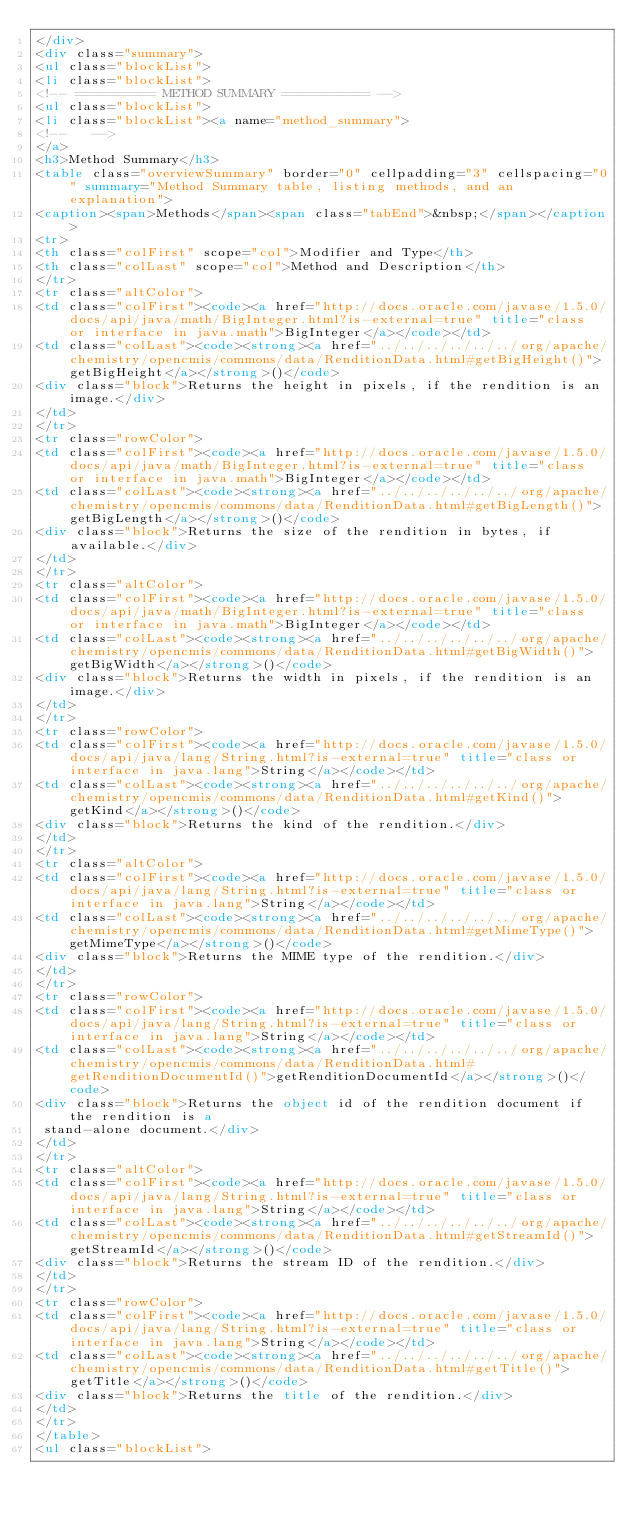Convert code to text. <code><loc_0><loc_0><loc_500><loc_500><_HTML_></div>
<div class="summary">
<ul class="blockList">
<li class="blockList">
<!-- ========== METHOD SUMMARY =========== -->
<ul class="blockList">
<li class="blockList"><a name="method_summary">
<!--   -->
</a>
<h3>Method Summary</h3>
<table class="overviewSummary" border="0" cellpadding="3" cellspacing="0" summary="Method Summary table, listing methods, and an explanation">
<caption><span>Methods</span><span class="tabEnd">&nbsp;</span></caption>
<tr>
<th class="colFirst" scope="col">Modifier and Type</th>
<th class="colLast" scope="col">Method and Description</th>
</tr>
<tr class="altColor">
<td class="colFirst"><code><a href="http://docs.oracle.com/javase/1.5.0/docs/api/java/math/BigInteger.html?is-external=true" title="class or interface in java.math">BigInteger</a></code></td>
<td class="colLast"><code><strong><a href="../../../../../../org/apache/chemistry/opencmis/commons/data/RenditionData.html#getBigHeight()">getBigHeight</a></strong>()</code>
<div class="block">Returns the height in pixels, if the rendition is an image.</div>
</td>
</tr>
<tr class="rowColor">
<td class="colFirst"><code><a href="http://docs.oracle.com/javase/1.5.0/docs/api/java/math/BigInteger.html?is-external=true" title="class or interface in java.math">BigInteger</a></code></td>
<td class="colLast"><code><strong><a href="../../../../../../org/apache/chemistry/opencmis/commons/data/RenditionData.html#getBigLength()">getBigLength</a></strong>()</code>
<div class="block">Returns the size of the rendition in bytes, if available.</div>
</td>
</tr>
<tr class="altColor">
<td class="colFirst"><code><a href="http://docs.oracle.com/javase/1.5.0/docs/api/java/math/BigInteger.html?is-external=true" title="class or interface in java.math">BigInteger</a></code></td>
<td class="colLast"><code><strong><a href="../../../../../../org/apache/chemistry/opencmis/commons/data/RenditionData.html#getBigWidth()">getBigWidth</a></strong>()</code>
<div class="block">Returns the width in pixels, if the rendition is an image.</div>
</td>
</tr>
<tr class="rowColor">
<td class="colFirst"><code><a href="http://docs.oracle.com/javase/1.5.0/docs/api/java/lang/String.html?is-external=true" title="class or interface in java.lang">String</a></code></td>
<td class="colLast"><code><strong><a href="../../../../../../org/apache/chemistry/opencmis/commons/data/RenditionData.html#getKind()">getKind</a></strong>()</code>
<div class="block">Returns the kind of the rendition.</div>
</td>
</tr>
<tr class="altColor">
<td class="colFirst"><code><a href="http://docs.oracle.com/javase/1.5.0/docs/api/java/lang/String.html?is-external=true" title="class or interface in java.lang">String</a></code></td>
<td class="colLast"><code><strong><a href="../../../../../../org/apache/chemistry/opencmis/commons/data/RenditionData.html#getMimeType()">getMimeType</a></strong>()</code>
<div class="block">Returns the MIME type of the rendition.</div>
</td>
</tr>
<tr class="rowColor">
<td class="colFirst"><code><a href="http://docs.oracle.com/javase/1.5.0/docs/api/java/lang/String.html?is-external=true" title="class or interface in java.lang">String</a></code></td>
<td class="colLast"><code><strong><a href="../../../../../../org/apache/chemistry/opencmis/commons/data/RenditionData.html#getRenditionDocumentId()">getRenditionDocumentId</a></strong>()</code>
<div class="block">Returns the object id of the rendition document if the rendition is a
 stand-alone document.</div>
</td>
</tr>
<tr class="altColor">
<td class="colFirst"><code><a href="http://docs.oracle.com/javase/1.5.0/docs/api/java/lang/String.html?is-external=true" title="class or interface in java.lang">String</a></code></td>
<td class="colLast"><code><strong><a href="../../../../../../org/apache/chemistry/opencmis/commons/data/RenditionData.html#getStreamId()">getStreamId</a></strong>()</code>
<div class="block">Returns the stream ID of the rendition.</div>
</td>
</tr>
<tr class="rowColor">
<td class="colFirst"><code><a href="http://docs.oracle.com/javase/1.5.0/docs/api/java/lang/String.html?is-external=true" title="class or interface in java.lang">String</a></code></td>
<td class="colLast"><code><strong><a href="../../../../../../org/apache/chemistry/opencmis/commons/data/RenditionData.html#getTitle()">getTitle</a></strong>()</code>
<div class="block">Returns the title of the rendition.</div>
</td>
</tr>
</table>
<ul class="blockList"></code> 